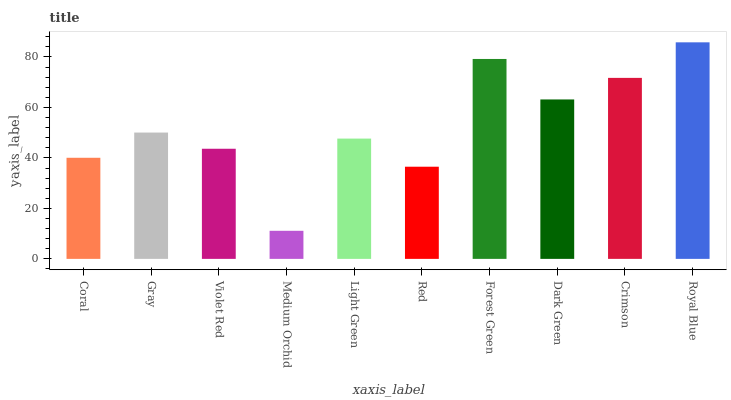Is Medium Orchid the minimum?
Answer yes or no. Yes. Is Royal Blue the maximum?
Answer yes or no. Yes. Is Gray the minimum?
Answer yes or no. No. Is Gray the maximum?
Answer yes or no. No. Is Gray greater than Coral?
Answer yes or no. Yes. Is Coral less than Gray?
Answer yes or no. Yes. Is Coral greater than Gray?
Answer yes or no. No. Is Gray less than Coral?
Answer yes or no. No. Is Gray the high median?
Answer yes or no. Yes. Is Light Green the low median?
Answer yes or no. Yes. Is Violet Red the high median?
Answer yes or no. No. Is Violet Red the low median?
Answer yes or no. No. 